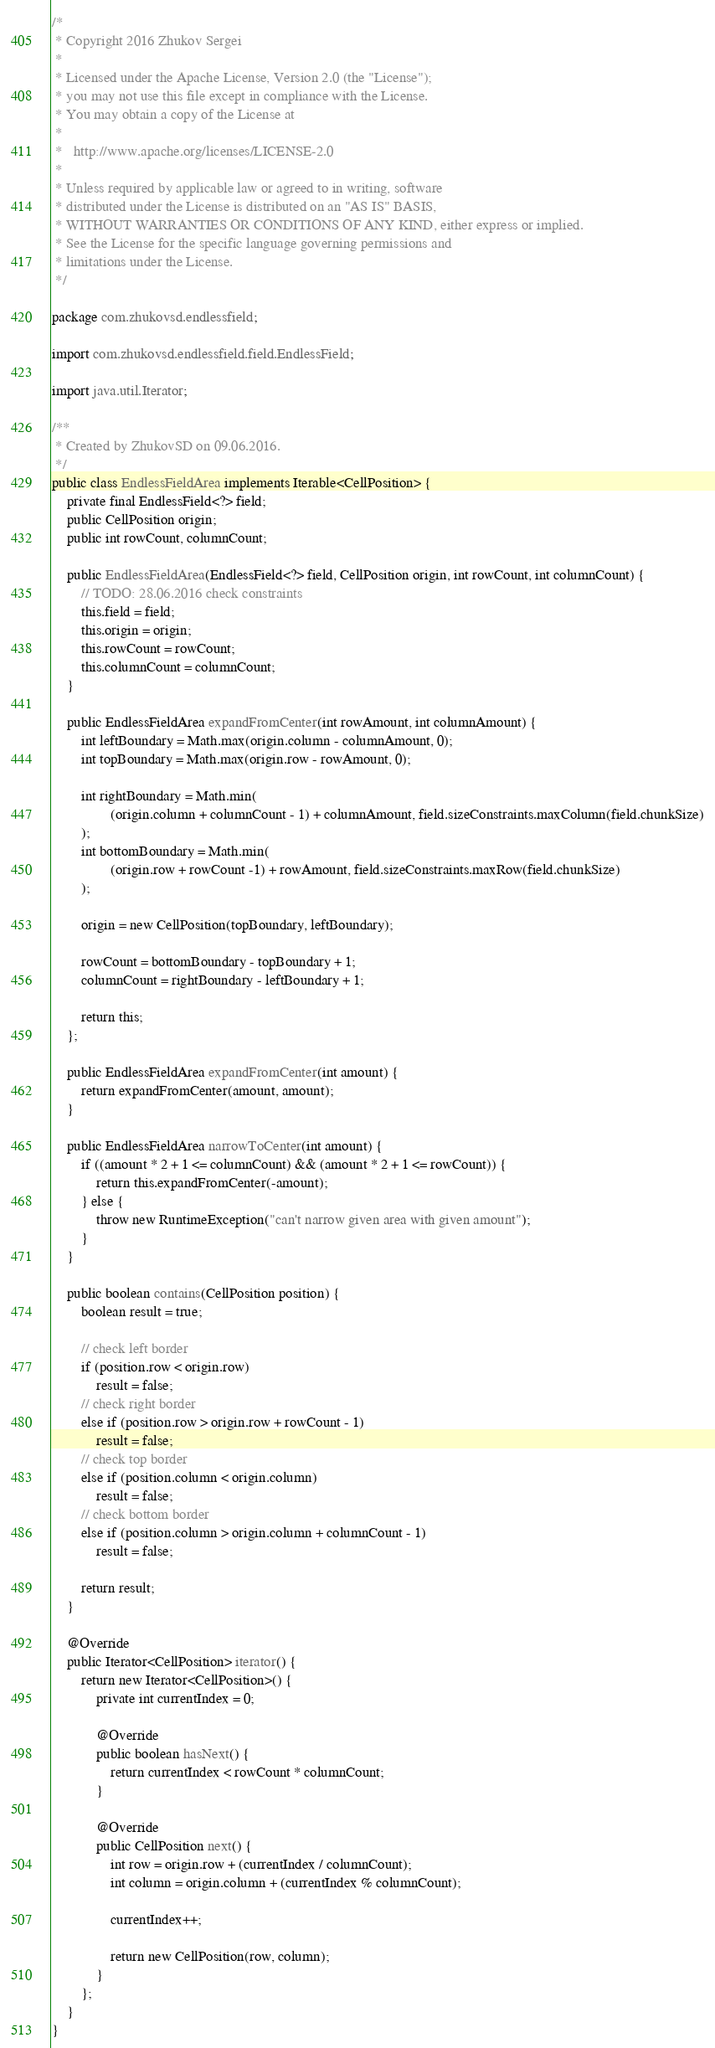Convert code to text. <code><loc_0><loc_0><loc_500><loc_500><_Java_>/*
 * Copyright 2016 Zhukov Sergei
 *
 * Licensed under the Apache License, Version 2.0 (the "License");
 * you may not use this file except in compliance with the License.
 * You may obtain a copy of the License at
 *
 *   http://www.apache.org/licenses/LICENSE-2.0
 *
 * Unless required by applicable law or agreed to in writing, software
 * distributed under the License is distributed on an "AS IS" BASIS,
 * WITHOUT WARRANTIES OR CONDITIONS OF ANY KIND, either express or implied.
 * See the License for the specific language governing permissions and
 * limitations under the License.
 */

package com.zhukovsd.endlessfield;

import com.zhukovsd.endlessfield.field.EndlessField;

import java.util.Iterator;

/**
 * Created by ZhukovSD on 09.06.2016.
 */
public class EndlessFieldArea implements Iterable<CellPosition> {
    private final EndlessField<?> field;
    public CellPosition origin;
    public int rowCount, columnCount;

    public EndlessFieldArea(EndlessField<?> field, CellPosition origin, int rowCount, int columnCount) {
        // TODO: 28.06.2016 check constraints
        this.field = field;
        this.origin = origin;
        this.rowCount = rowCount;
        this.columnCount = columnCount;
    }

    public EndlessFieldArea expandFromCenter(int rowAmount, int columnAmount) {
        int leftBoundary = Math.max(origin.column - columnAmount, 0);
        int topBoundary = Math.max(origin.row - rowAmount, 0);

        int rightBoundary = Math.min(
                (origin.column + columnCount - 1) + columnAmount, field.sizeConstraints.maxColumn(field.chunkSize)
        );
        int bottomBoundary = Math.min(
                (origin.row + rowCount -1) + rowAmount, field.sizeConstraints.maxRow(field.chunkSize)
        );

        origin = new CellPosition(topBoundary, leftBoundary);

        rowCount = bottomBoundary - topBoundary + 1;
        columnCount = rightBoundary - leftBoundary + 1;

        return this;
    };

    public EndlessFieldArea expandFromCenter(int amount) {
        return expandFromCenter(amount, amount);
    }

    public EndlessFieldArea narrowToCenter(int amount) {
        if ((amount * 2 + 1 <= columnCount) && (amount * 2 + 1 <= rowCount)) {
            return this.expandFromCenter(-amount);
        } else {
            throw new RuntimeException("can't narrow given area with given amount");
        }
    }

    public boolean contains(CellPosition position) {
        boolean result = true;

        // check left border
        if (position.row < origin.row)
            result = false;
        // check right border
        else if (position.row > origin.row + rowCount - 1)
            result = false;
        // check top border
        else if (position.column < origin.column)
            result = false;
        // check bottom border
        else if (position.column > origin.column + columnCount - 1)
            result = false;

        return result;
    }

    @Override
    public Iterator<CellPosition> iterator() {
        return new Iterator<CellPosition>() {
            private int currentIndex = 0;

            @Override
            public boolean hasNext() {
                return currentIndex < rowCount * columnCount;
            }

            @Override
            public CellPosition next() {
                int row = origin.row + (currentIndex / columnCount);
                int column = origin.column + (currentIndex % columnCount);

                currentIndex++;

                return new CellPosition(row, column);
            }
        };
    }
}
</code> 